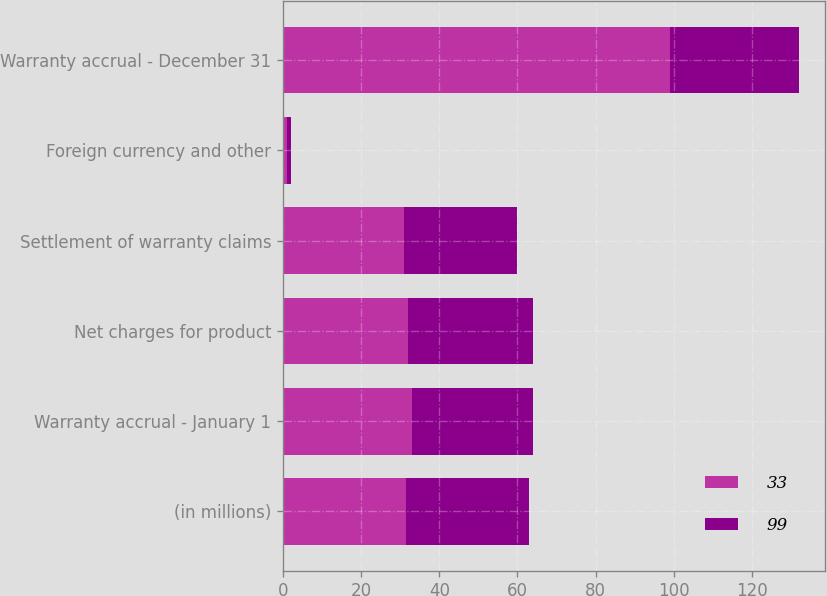Convert chart. <chart><loc_0><loc_0><loc_500><loc_500><stacked_bar_chart><ecel><fcel>(in millions)<fcel>Warranty accrual - January 1<fcel>Net charges for product<fcel>Settlement of warranty claims<fcel>Foreign currency and other<fcel>Warranty accrual - December 31<nl><fcel>33<fcel>31.5<fcel>33<fcel>32<fcel>31<fcel>1<fcel>99<nl><fcel>99<fcel>31.5<fcel>31<fcel>32<fcel>29<fcel>1<fcel>33<nl></chart> 